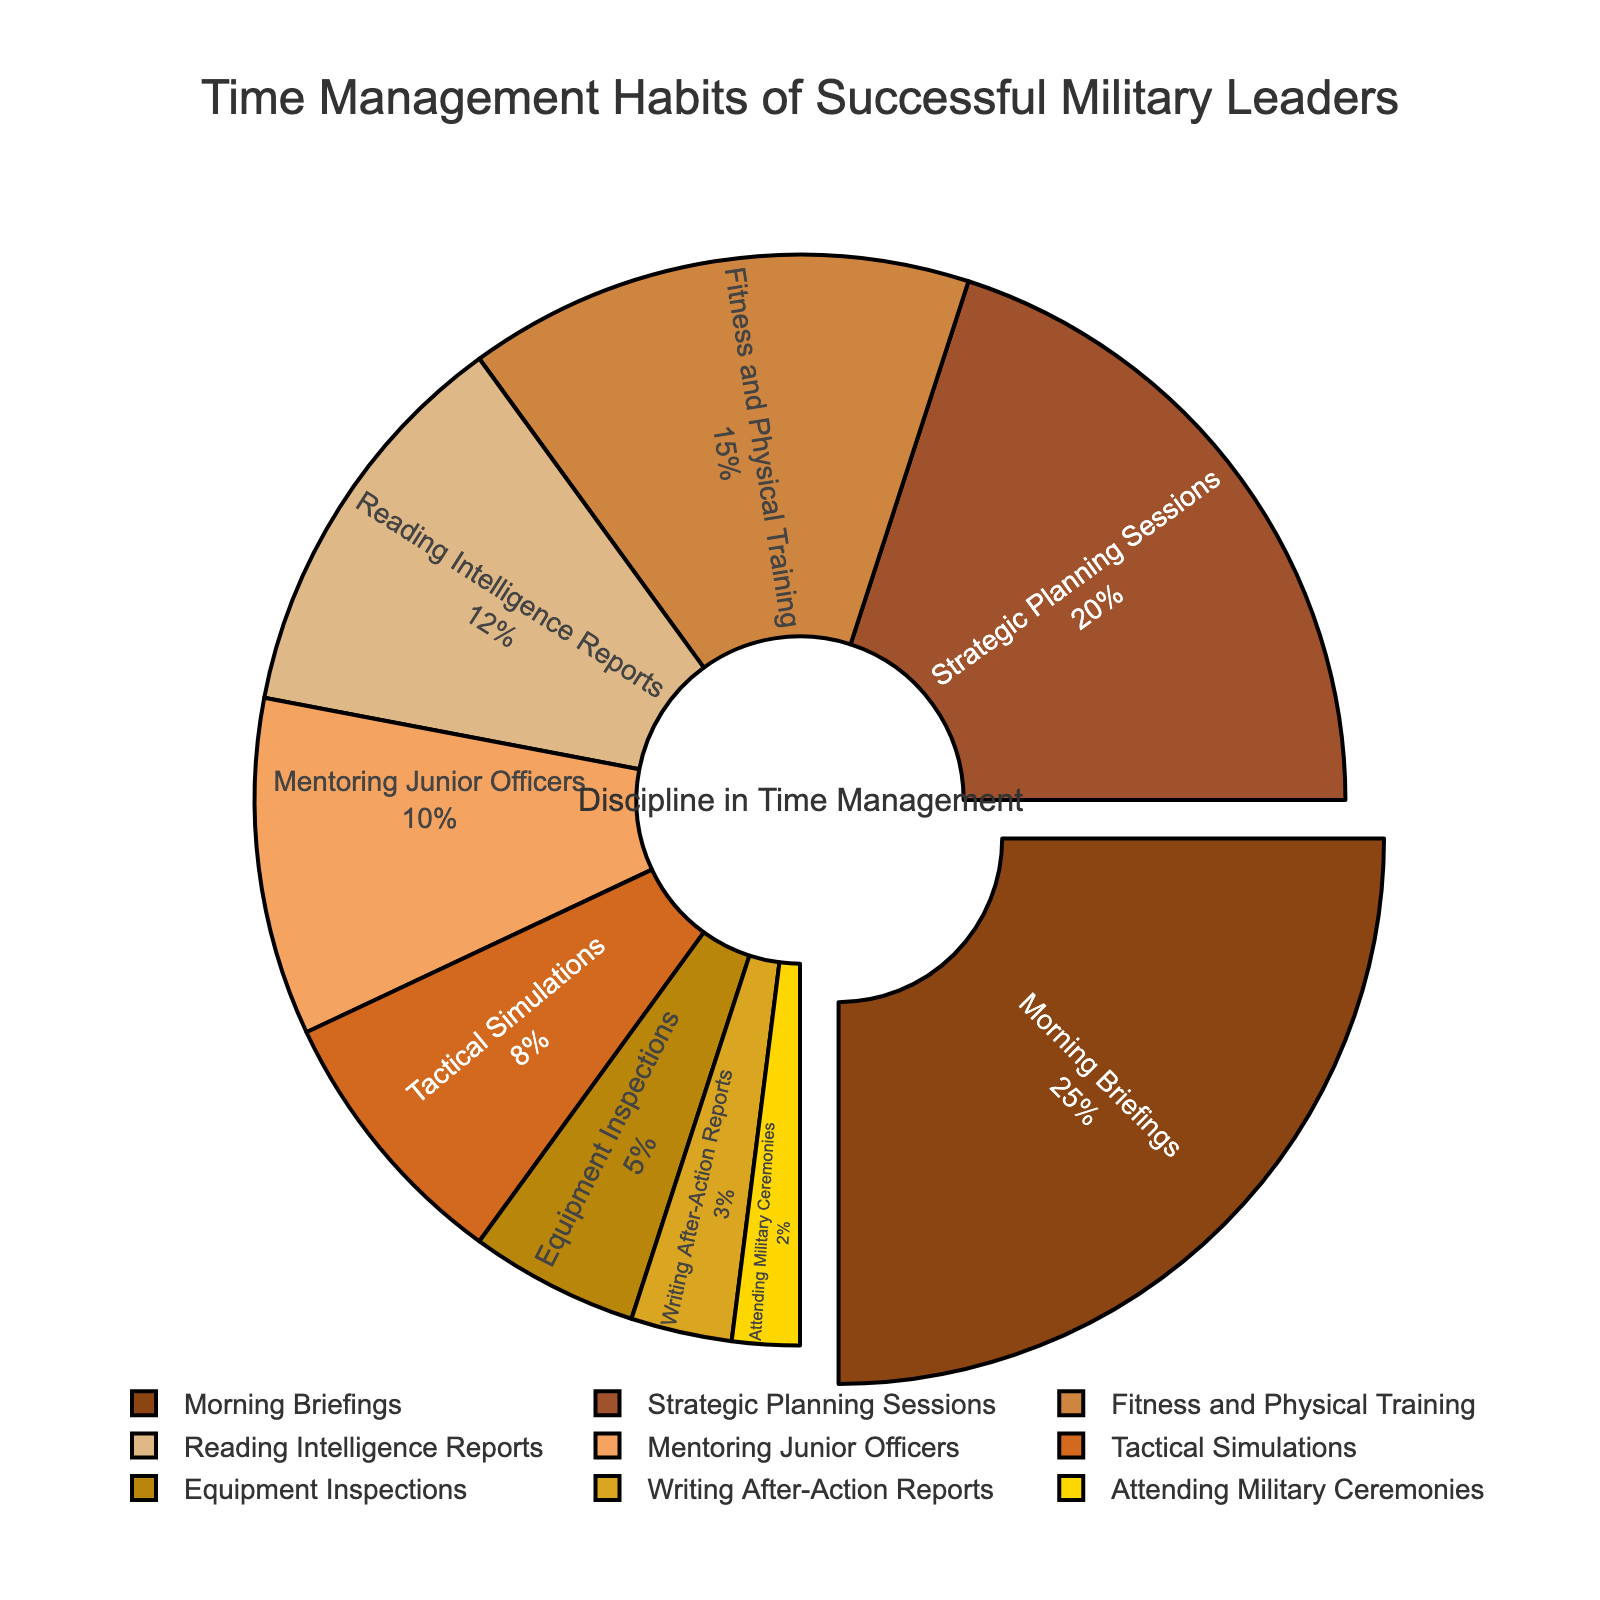Which time management habit takes up the largest percentage of time for successful military leaders? The pie chart shows various time management habits of military leaders and their respective percentages. The largest section of the pie chart, taking up 25%, is for Morning Briefings.
Answer: Morning Briefings How much more time is allocated to Strategic Planning Sessions compared to Writing After-Action Reports? The pie chart shows that Strategic Planning Sessions account for 20% of the time while Writing After-Action Reports account for 3%. The difference in their time allocation is 20% - 3% = 17%.
Answer: 17% What is the combined percentage of time spent on Fitness and Physical Training and Reading Intelligence Reports? The pie chart shows that Fitness and Physical Training takes up 15% of the time and Reading Intelligence Reports takes up 12%. Adding these together gives 15% + 12% = 27%.
Answer: 27% Which activities are given less than 10% of the time each? The pie chart illustrates the different activities and their time allocation. The activities with less than 10% are Tactical Simulations (8%), Equipment Inspections (5%), Writing After-Action Reports (3%), and Attending Military Ceremonies (2%).
Answer: Tactical Simulations, Equipment Inspections, Writing After-Action Reports, Attending Military Ceremonies Is more time spent on Mentoring Junior Officers or on Equipment Inspections? By how much? The pie chart shows that Mentoring Junior Officers takes up 10% of the time while Equipment Inspections account for 5%. The difference in their time allocation is 10% - 5% = 5%.
Answer: Mentoring Junior Officers by 5% What percentage of time is dedicated to activities other than Morning Briefings and Strategic Planning Sessions? The pie chart shows that Morning Briefings take 25% and Strategic Planning Sessions take 20%. The remaining time percentage is 100% - 25% - 20% = 55%.
Answer: 55% If the Military Ceremonies percentage were to double, what would it become? The current percentage for Attending Military Ceremonies is 2%. If this value were to double, it would become 2% * 2 = 4%.
Answer: 4% How do the sizes of sections representing Fitness and Physical Training and Reading Intelligence Reports compare in color? The two sections representing Fitness and Physical Training and Reading Intelligence Reports are distinguishable by their different shades of brown used in the pie chart.
Answer: Different shades of brown Which time management habit appears closest to the annotation "Discipline in Time Management"? The annotation "Discipline in Time Management" is located at the center of the pie chart. The closest segment to this annotation is the section for Morning Briefings, which has a slight pull highlighting its significance.
Answer: Morning Briefings Does any section of the pie chart have a visual pull effect? Yes, the pie chart has a pull effect on the section representing Morning Briefings, indicating its prominence with the highest percentage.
Answer: Morning Briefings 